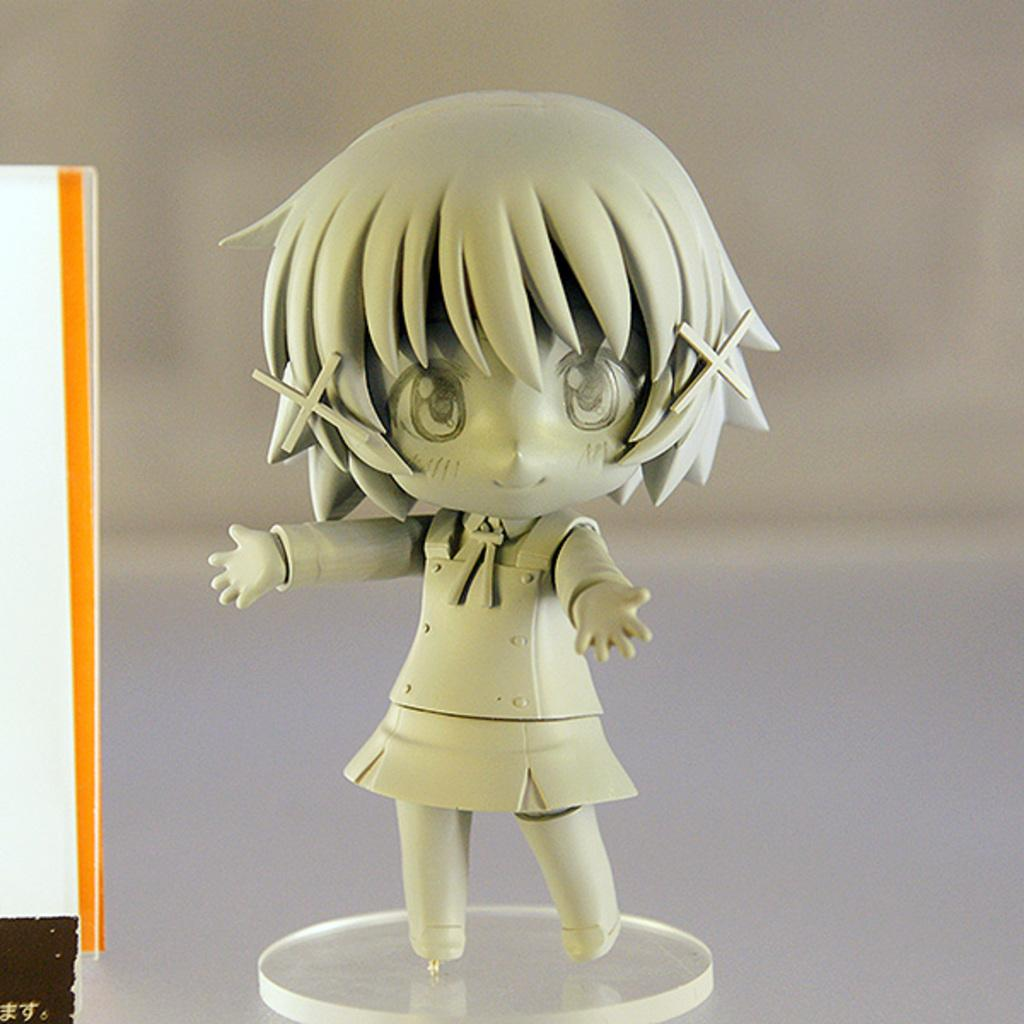What type of toy is present in the image? There is an animation girl toy in the image. Where is the toy placed in the image? The animation girl toy is kept on a plate. What type of grass is growing in the pot next to the animation girl toy? There is no grass or pot present in the image; it only features the animation girl toy on a plate. 